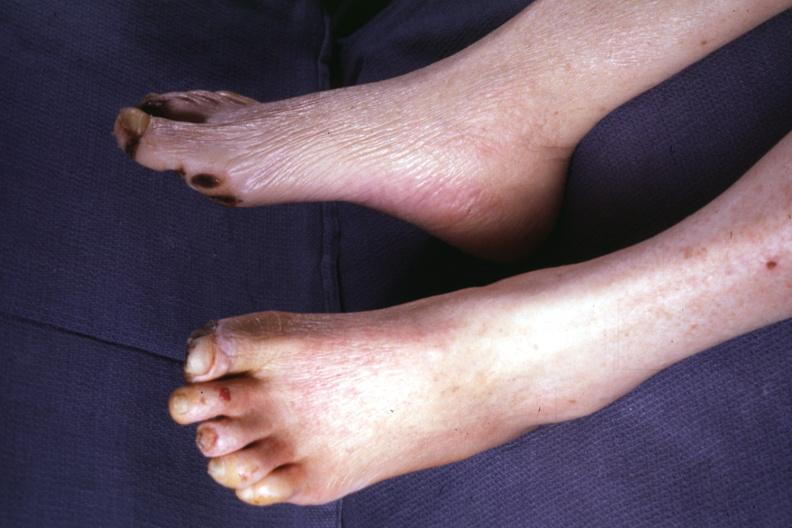re extremities present?
Answer the question using a single word or phrase. Yes 